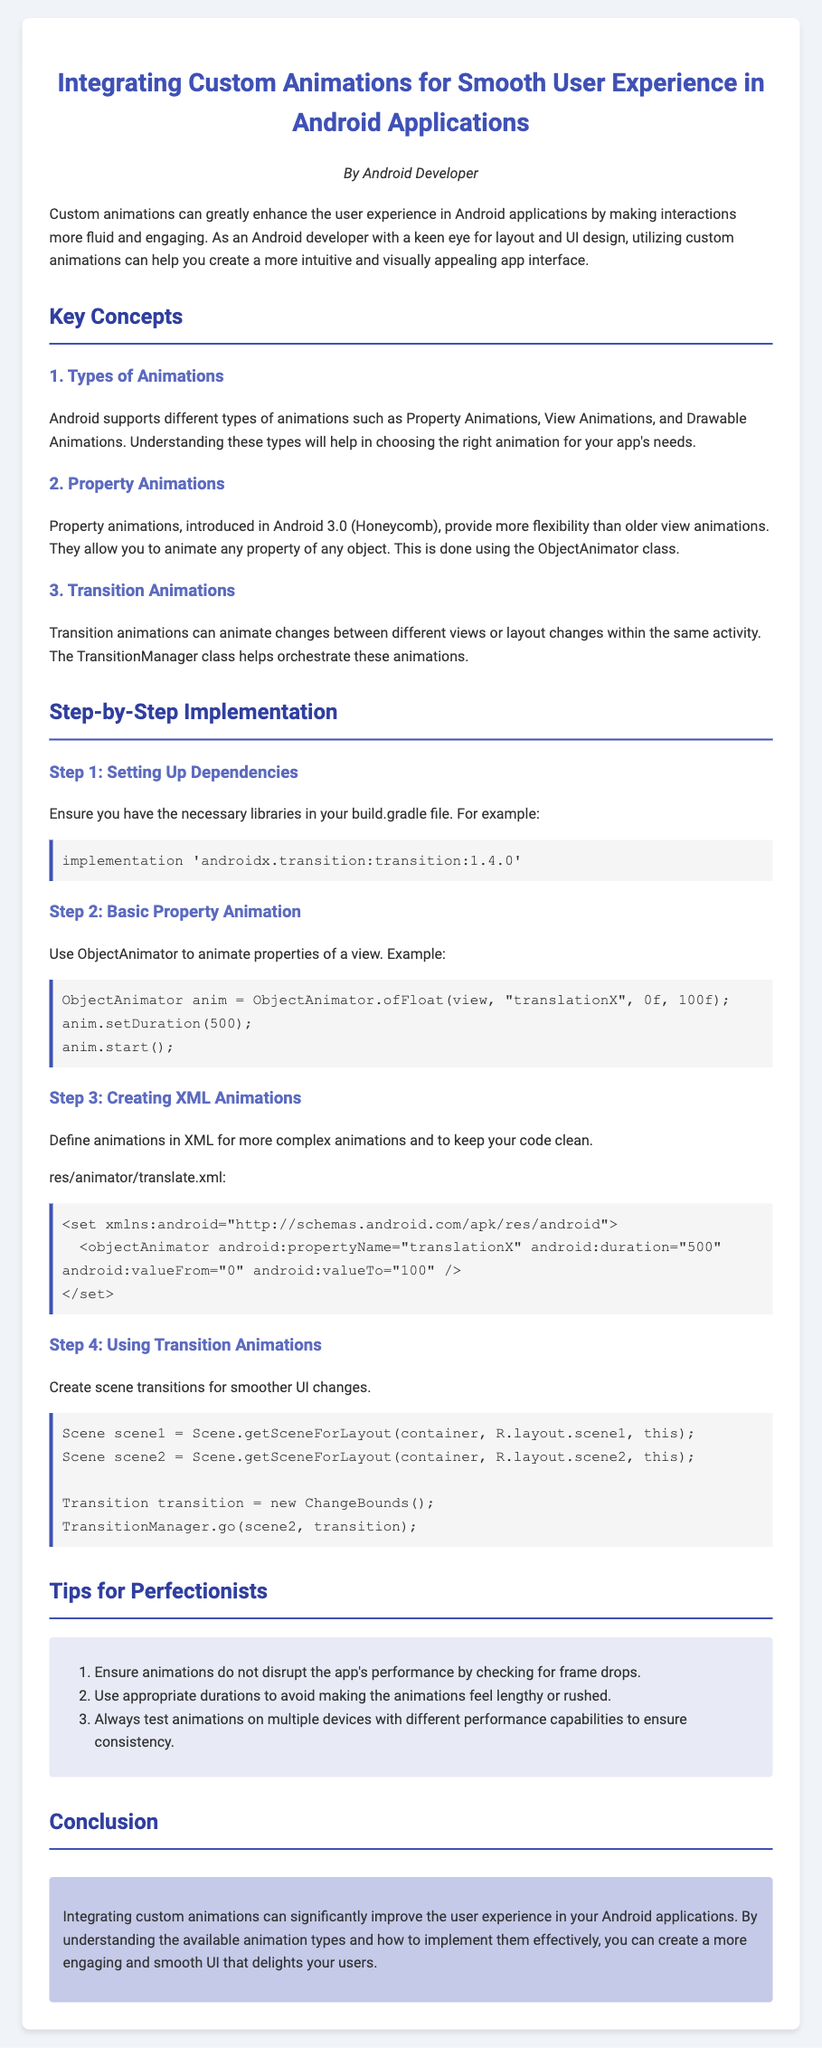What is the title of the document? The title is prominently displayed at the top of the document, indicating the main topic discussed.
Answer: Integrating Custom Animations for Smooth User Experience in Android Applications Who authored the document? The author is mentioned below the title, providing attribution for the content.
Answer: Android Developer What is the latest version of the transition library mentioned? The document specifies the version needed for dependencies in a specific code section.
Answer: 1.4.0 What are the types of animations discussed in the document? The document lists different animation types under a distinct section heading.
Answer: Property Animations, View Animations, and Drawable Animations Which class is used for property animations? The document specifies a class that allows for animating properties of objects in the context of property animations.
Answer: ObjectAnimator What should you ensure to avoid performance issues with animations? A tip is provided in the document to ensure smooth performance of animations.
Answer: Checking for frame drops How can XML be utilized in animations according to the document? The document explains using XML files for defining more complex animations.
Answer: To keep your code clean What is an example of a transition animation code block mentioned? The document provides a snippet to illustrate the transition animation process.
Answer: Scene and TransitionManager What is the conclusion about integrating custom animations? The conclusion summarizes the key benefit of utilizing custom animations in applications.
Answer: Significantly improve user experience 